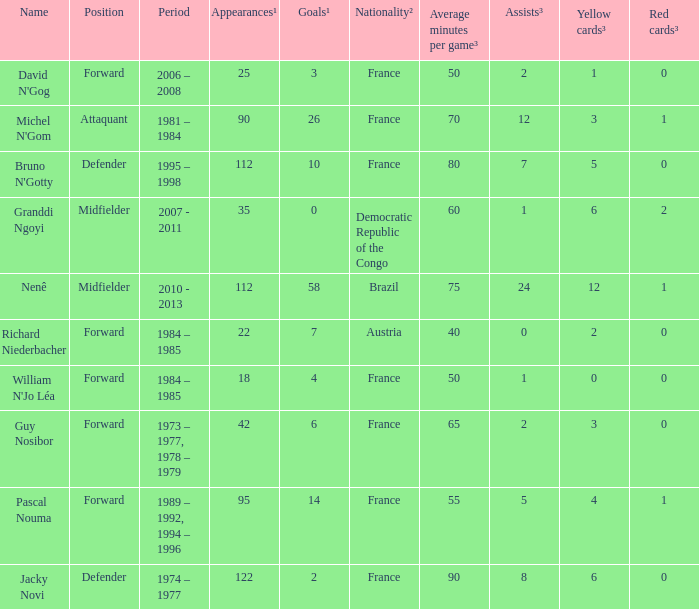How many games had less than 7 goals scored? 1.0. Could you parse the entire table as a dict? {'header': ['Name', 'Position', 'Period', 'Appearances¹', 'Goals¹', 'Nationality²', 'Average minutes per game³', 'Assists³', 'Yellow cards³', 'Red cards³'], 'rows': [["David N'Gog", 'Forward', '2006 – 2008', '25', '3', 'France', '50', '2', '1', '0'], ["Michel N'Gom", 'Attaquant', '1981 – 1984', '90', '26', 'France', '70', '12', '3', '1'], ["Bruno N'Gotty", 'Defender', '1995 – 1998', '112', '10', 'France', '80', '7', '5', '0'], ['Granddi Ngoyi', 'Midfielder', '2007 - 2011', '35', '0', 'Democratic Republic of the Congo', '60', '1', '6', '2'], ['Nenê', 'Midfielder', '2010 - 2013', '112', '58', 'Brazil', '75', '24', '12', '1'], ['Richard Niederbacher', 'Forward', '1984 – 1985', '22', '7', 'Austria', '40', '0', '2', '0'], ["William N'Jo Léa", 'Forward', '1984 – 1985', '18', '4', 'France', '50', '1', '0', '0'], ['Guy Nosibor', 'Forward', '1973 – 1977, 1978 – 1979', '42', '6', 'France', '65', '2', '3', '0'], ['Pascal Nouma', 'Forward', '1989 – 1992, 1994 – 1996', '95', '14', 'France', '55', '5', '4', '1'], ['Jacky Novi', 'Defender', '1974 – 1977', '122', '2', 'France', '90', '8', '6', '0']]} 